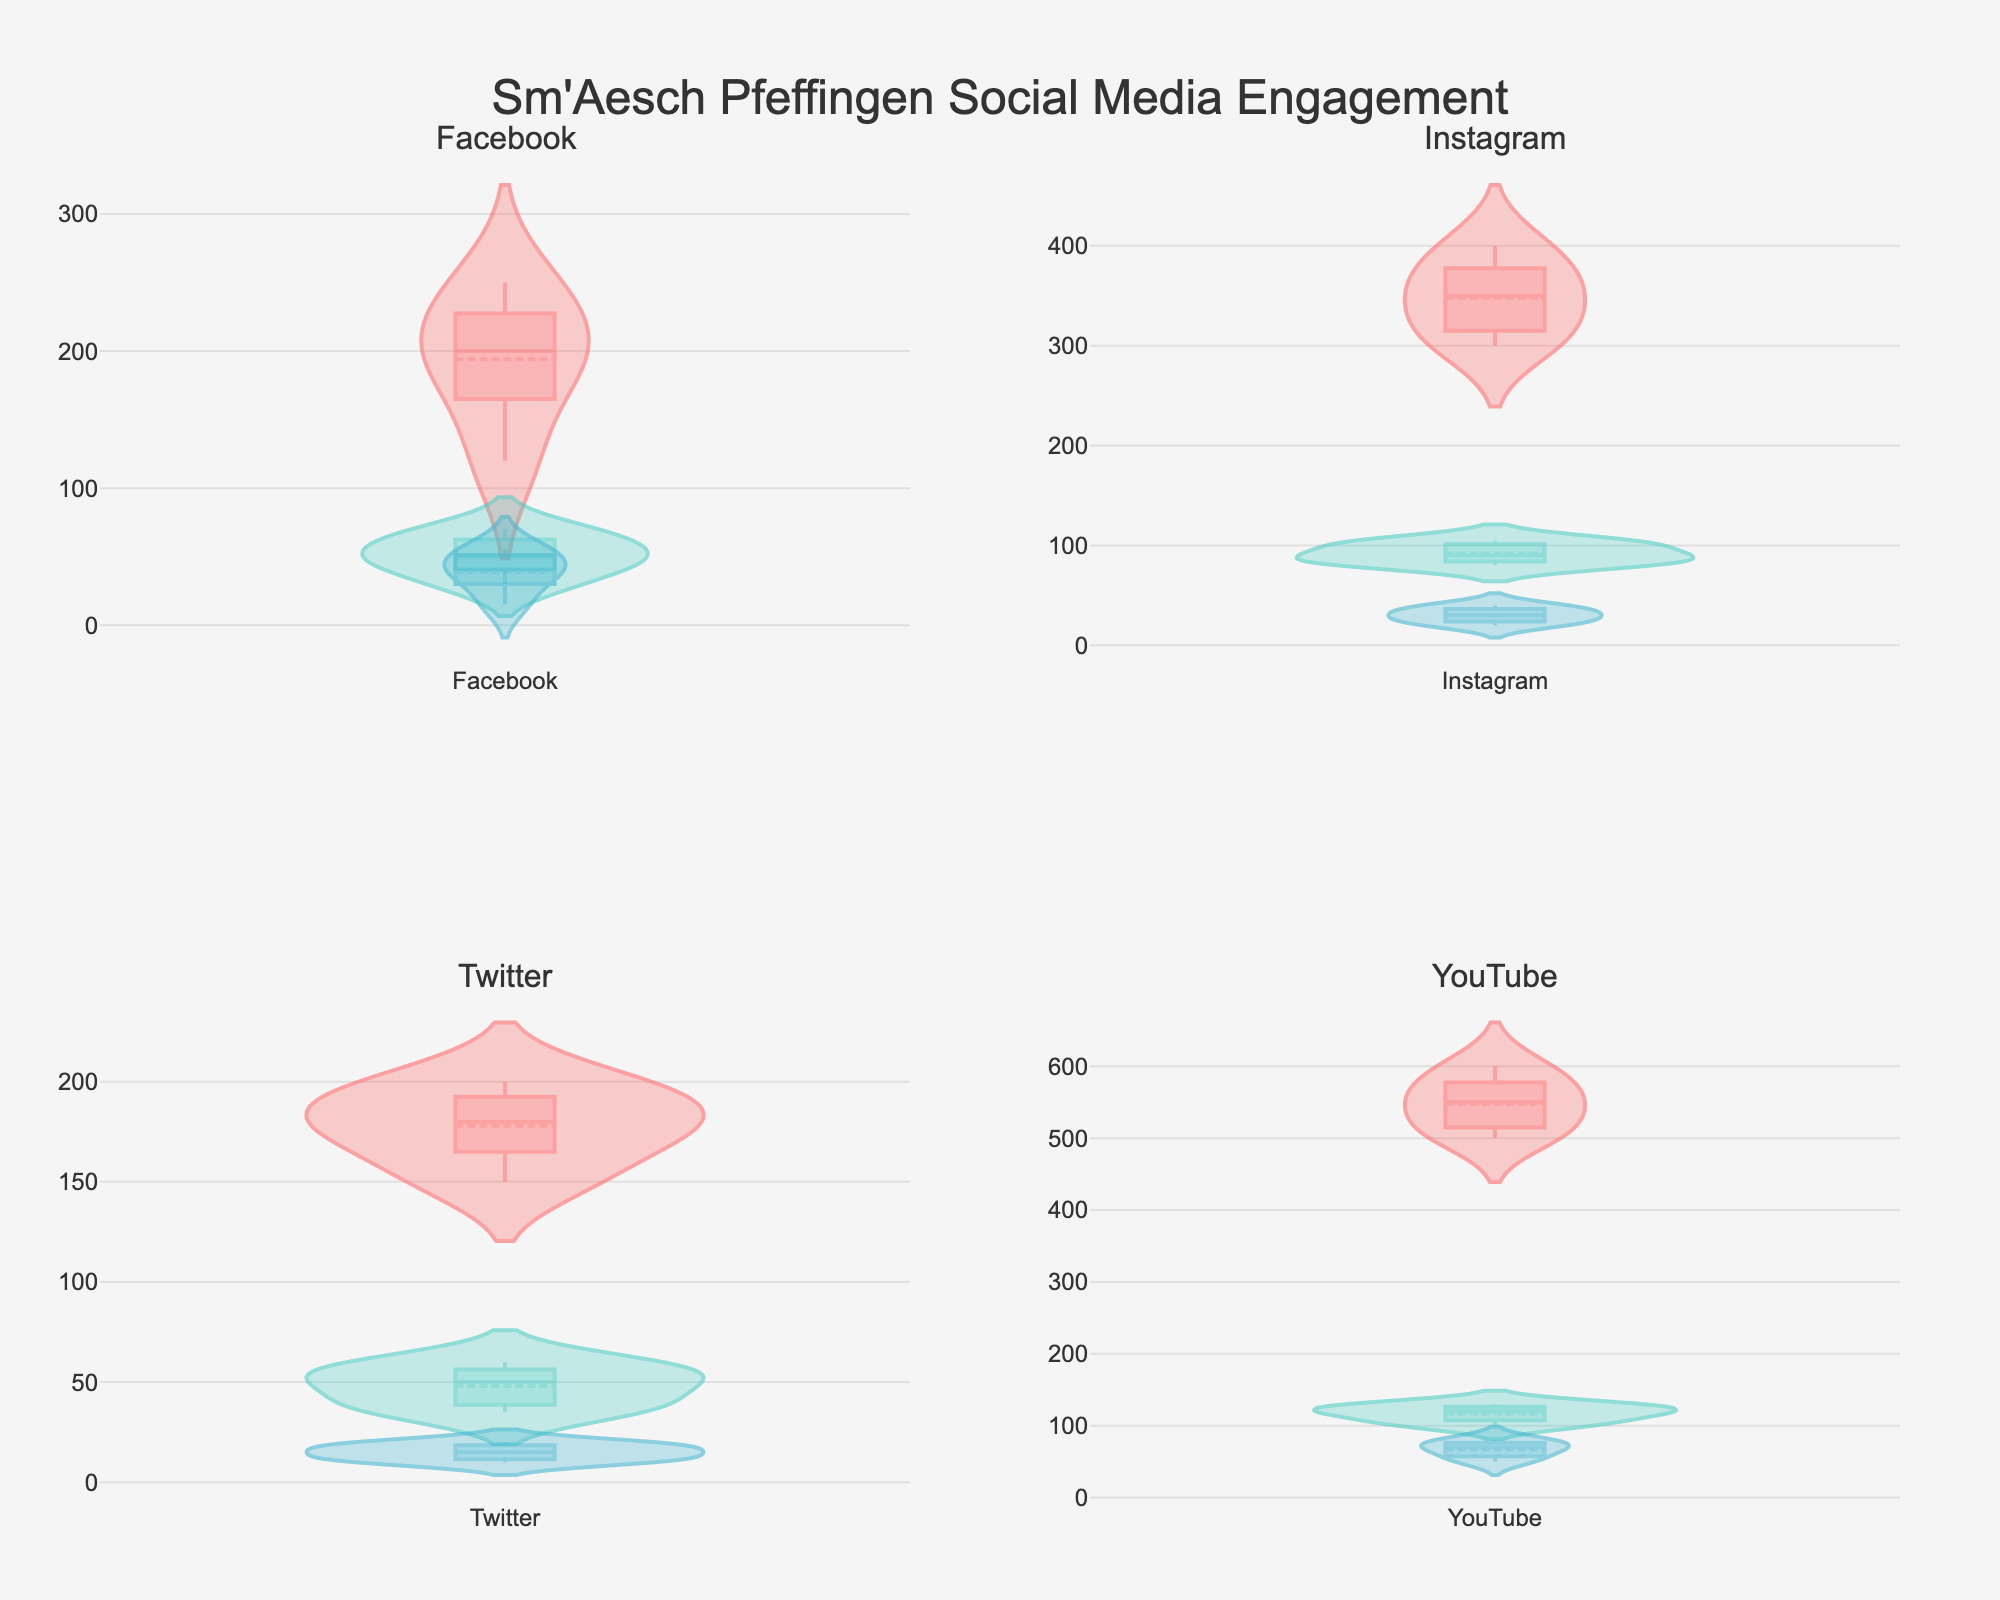What is the title of the figure? The title is displayed at the top of the figure. By visually examining the placement and font size, it is apparent that the title is "Sm'Aesch Pfeffingen Social Media Engagement".
Answer: "Sm'Aesch Pfeffingen Social Media Engagement" Which platform has the highest median number of Likes? To determine the platform with the highest median number of Likes, examine the vertical position of the median lines within the violin plots for the Likes category across all platforms. The highest median line by value appears in the YouTube subplot.
Answer: YouTube On which platform do posts have the widest range of Comments? To identify the platform with the widest range of Comments, look for the lengthiest vertical spread in the Comments violin plot. The platform with the broadest range in the Comments plot is YouTube.
Answer: YouTube What is the average range of Shares on Facebook? To calculate the average range of Shares on Facebook, identify the highest and lowest points of the Shares violin plot on the Facebook subplot. The highest value is approximately 70 and the lowest is 30. The range is therefore 70 - 30 = 40.
Answer: 40 Which social media platform shows consistent levels of Comments over time? Consistency in Comments can be gauged by a narrower spread of the violin plot. Comparing all platforms, Twitter has the narrowest Comments violin plot, indicating more consistent comment levels.
Answer: Twitter Between Instagram and Facebook, which platform sees higher engagement in terms of Likes? Comparing the vertical extent and median lines of the Likes violin plots for Instagram and Facebook shows that Instagram has both a higher median and a taller spread, indicating higher engagement.
Answer: Instagram What is the middle value of Twitter Shares? The middle or median value of Twitter Shares can be interpreted from the horizontal median line within the Shares violin plot on the Twitter subplot. This middle value appears to be around 50.
Answer: 50 Which platform has the least variability in the number of Shares? Variability can be assessed by the overall spread of the Shares violin plots across all platforms. The smallest spread, indicating least variability, is observed for Facebook.
Answer: Facebook If you sum the highest median Likes of each platform, what is the resulting value? Adding the highest median Likes from each platform involves: Facebook (around 220), Instagram (around 370), Twitter (around 180), and YouTube (around 550). Summing these gives 220 + 370 + 180 + 550 = 1320.
Answer: 1320 